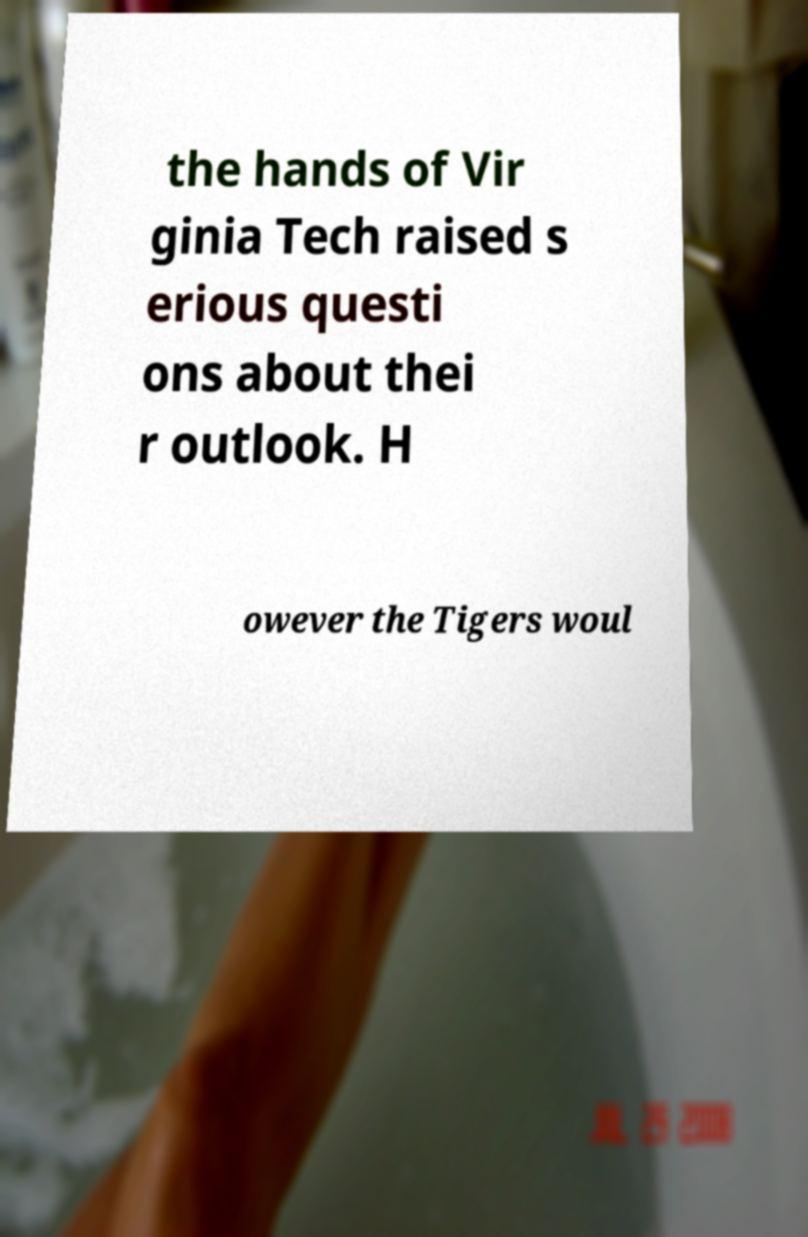Could you extract and type out the text from this image? the hands of Vir ginia Tech raised s erious questi ons about thei r outlook. H owever the Tigers woul 